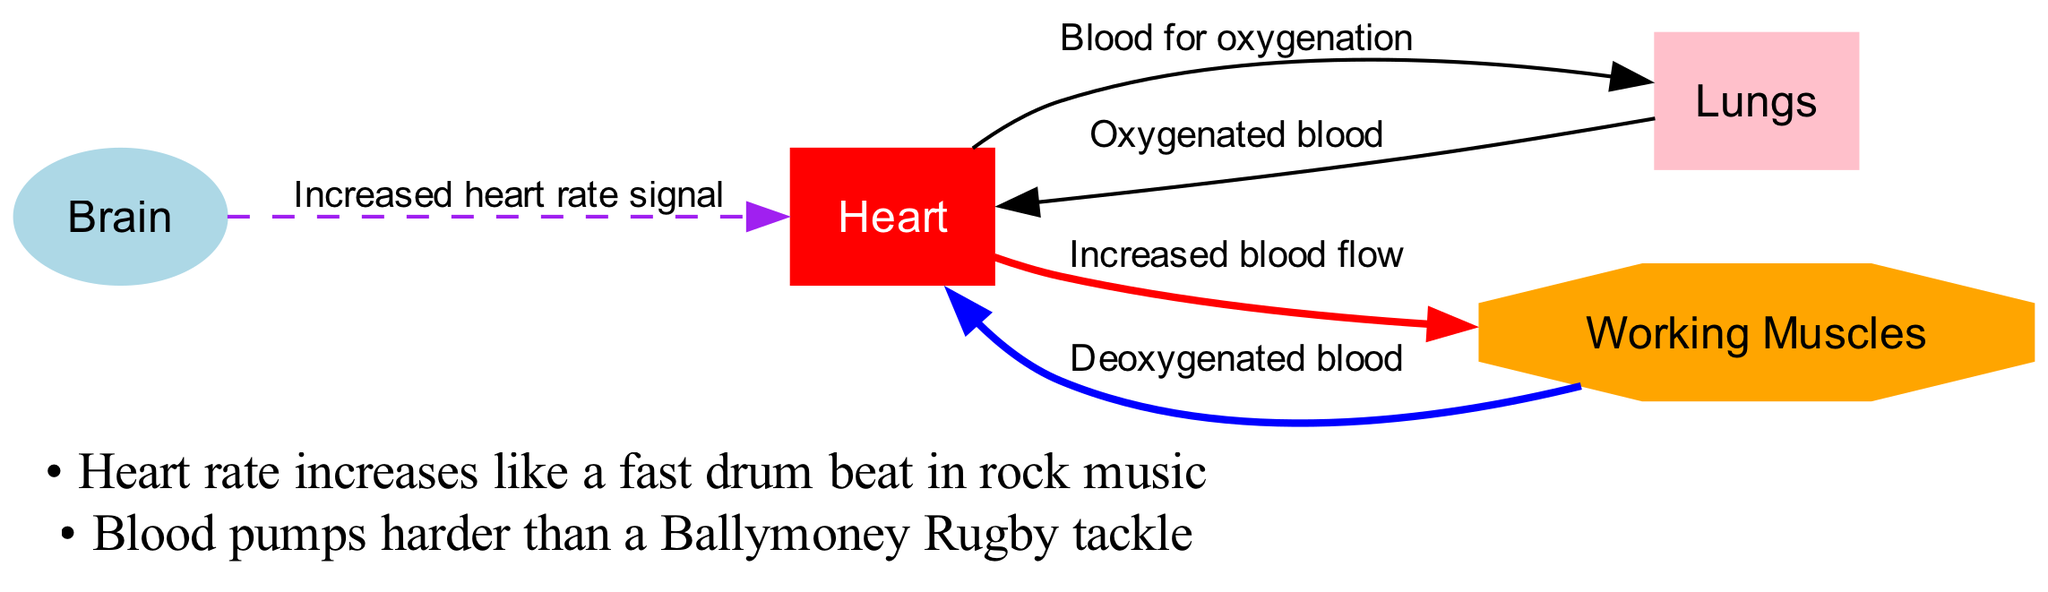What are the four main nodes in the diagram? The nodes listed in the diagram are Heart, Lungs, Working Muscles, and Brain. These nodes represent key components in the circulatory system during physical activity.
Answer: Heart, Lungs, Working Muscles, Brain How many edges are there in the diagram? The diagram has five edges connecting the nodes, indicating the flow of blood and signals between the components of the circulatory system.
Answer: 5 What is the relationship between the heart and working muscles? The diagram indicates that there is "Increased blood flow" from the Heart to the Working Muscles. This shows that during intense physical activity, the heart supplies more blood to the muscles.
Answer: Increased blood flow What type of blood does the heart receive from the muscles? According to the diagram, the heart receives "Deoxygenated blood" from the Working Muscles, which indicates that this blood has lost oxygen during the muscles' exertion.
Answer: Deoxygenated blood What signal does the brain send to the heart during intense physical activity? The diagram shows that the brain sends an "Increased heart rate signal" to the heart when physical activity intensifies, influencing the heart's performance.
Answer: Increased heart rate signal How does the heart assist the lungs during exercise? The heart sends "Blood for oxygenation" to the Lungs, indicating that during exercise, the heart plays a crucial role in transporting blood to the lungs for oxygen replenishment.
Answer: Blood for oxygenation What type of blood does the heart receive from the lungs? The diagram specifies that the heart receives "Oxygenated blood" from the Lungs, which is vital for supplying oxygen to the rest of the body during physical activity.
Answer: Oxygenated blood What do the annotations in the diagram highlight about the heart rate? The annotations state that the heart rate "increases like a fast drum beat in rock music," indicating that physical activity elevates the heart's rhythm significantly.
Answer: Increases like a fast drum beat in rock music What does the second annotation compare blood pumping to? The second annotation compares blood pumping to a "Ballymoney Rugby tackle," suggesting the intensity and effort involved in the heart's response during intense activities.
Answer: A Ballymoney Rugby tackle 